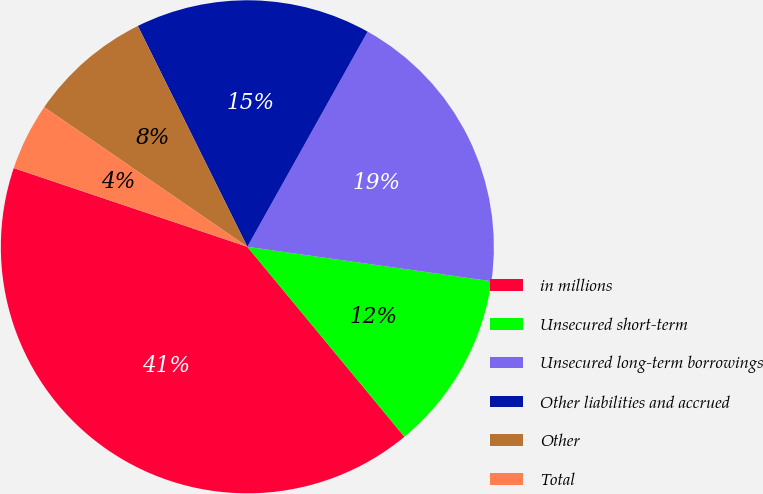Convert chart to OTSL. <chart><loc_0><loc_0><loc_500><loc_500><pie_chart><fcel>in millions<fcel>Unsecured short-term<fcel>Unsecured long-term borrowings<fcel>Other liabilities and accrued<fcel>Other<fcel>Total<nl><fcel>41.17%<fcel>11.77%<fcel>19.12%<fcel>15.44%<fcel>8.09%<fcel>4.41%<nl></chart> 